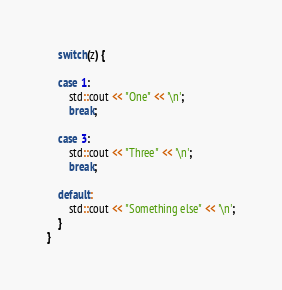<code> <loc_0><loc_0><loc_500><loc_500><_C++_>	switch(z) {

	case 1:
		std::cout << "One" << '\n';
		break;

	case 3:
		std::cout << "Three" << '\n';
		break;

	default:
		std::cout << "Something else" << '\n';
	}
}

</code> 